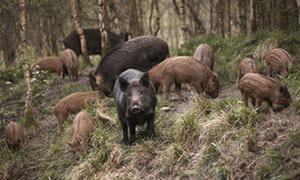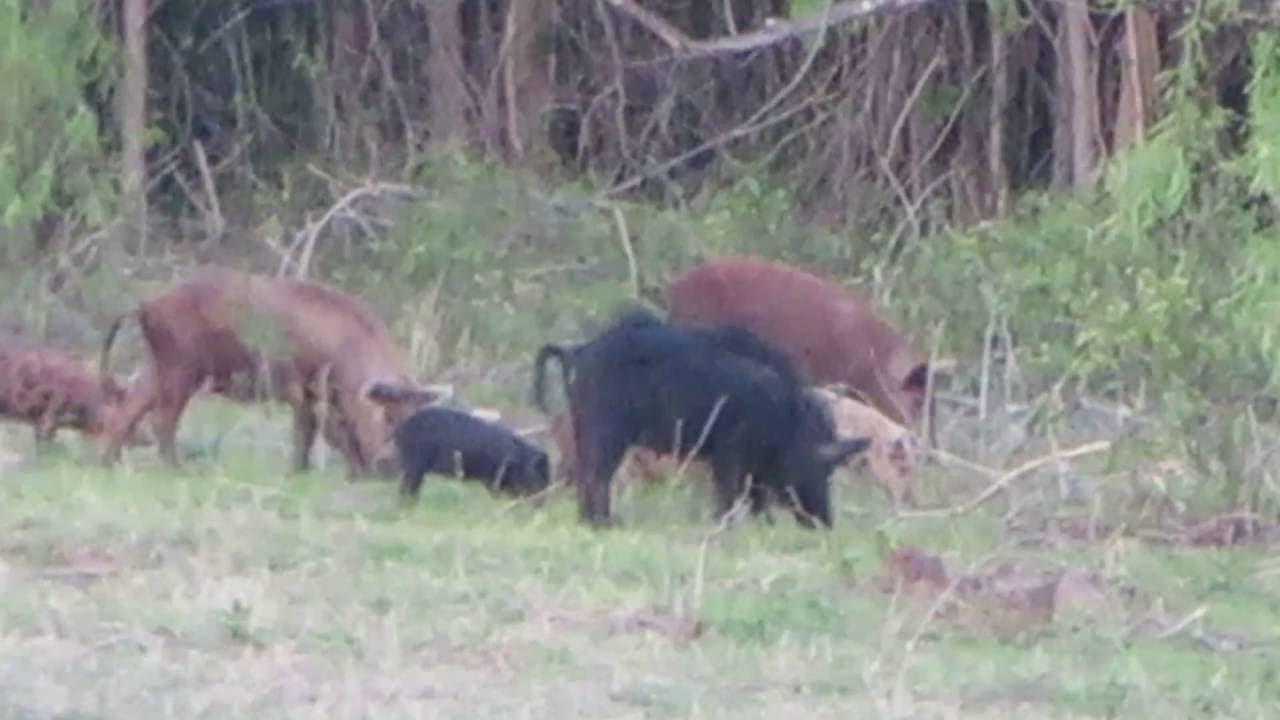The first image is the image on the left, the second image is the image on the right. For the images shown, is this caption "All boars in the right image are facing right." true? Answer yes or no. Yes. The first image is the image on the left, the second image is the image on the right. For the images displayed, is the sentence "An image contains multiple dark adult boars, and at least seven striped juvenile pigs." factually correct? Answer yes or no. Yes. 